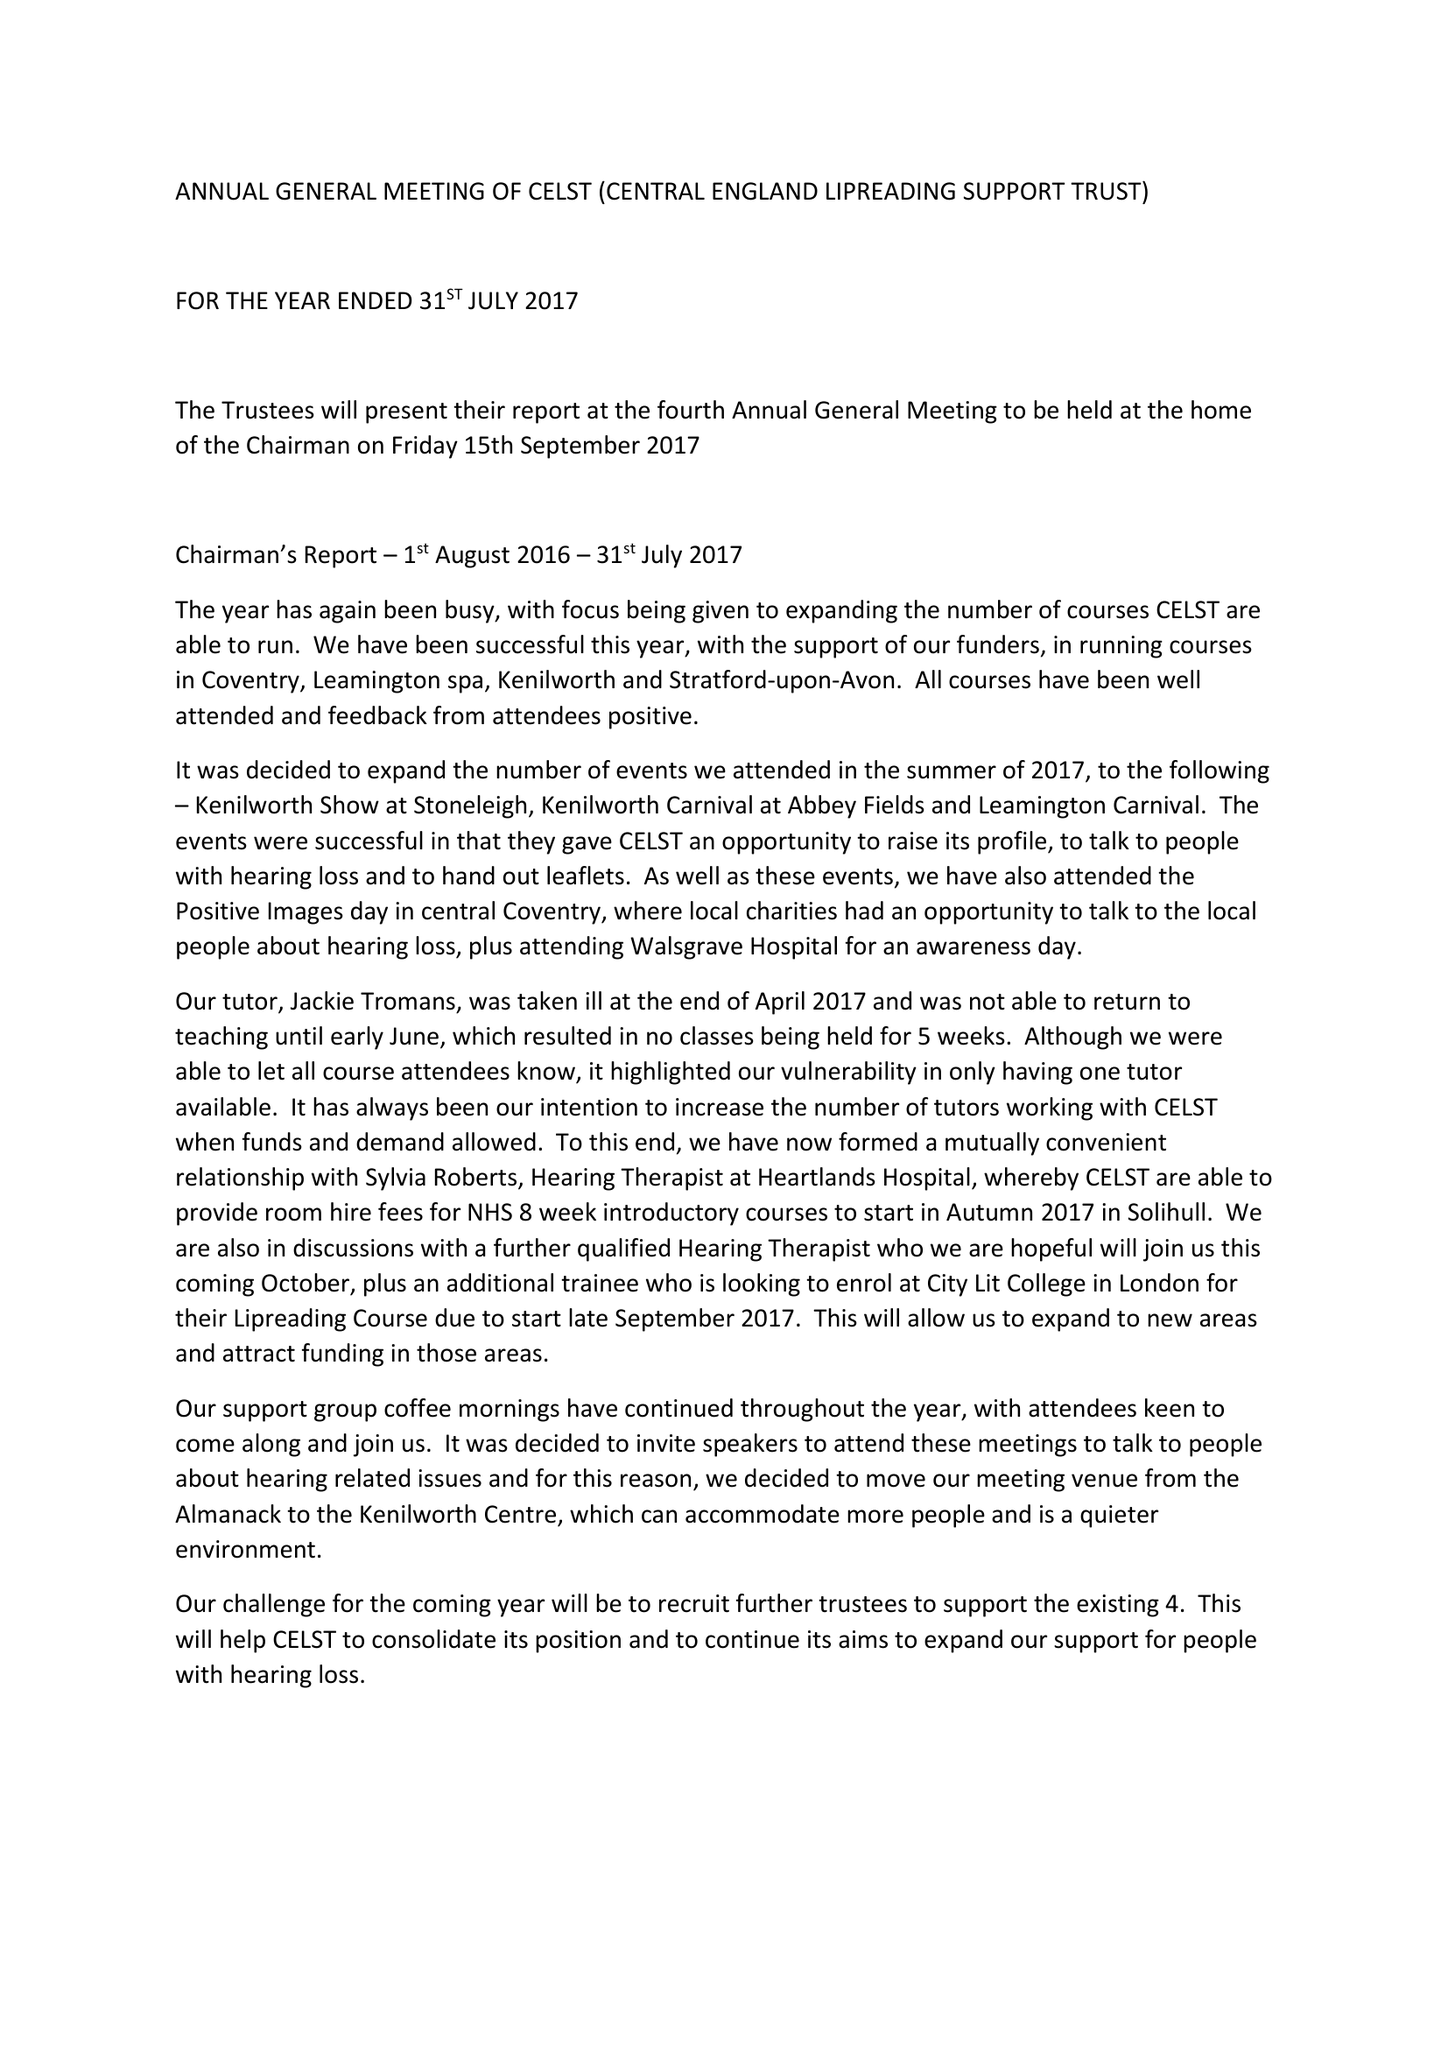What is the value for the income_annually_in_british_pounds?
Answer the question using a single word or phrase. 20514.00 